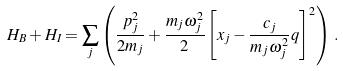<formula> <loc_0><loc_0><loc_500><loc_500>H _ { B } + H _ { I } = \sum _ { j } \left ( \frac { p _ { j } ^ { 2 } } { 2 m _ { j } } + \frac { m _ { j } \omega _ { j } ^ { 2 } } { 2 } \left [ x _ { j } - \frac { c _ { j } } { m _ { j } \omega _ { j } ^ { 2 } } q \right ] ^ { 2 } \right ) \, .</formula> 